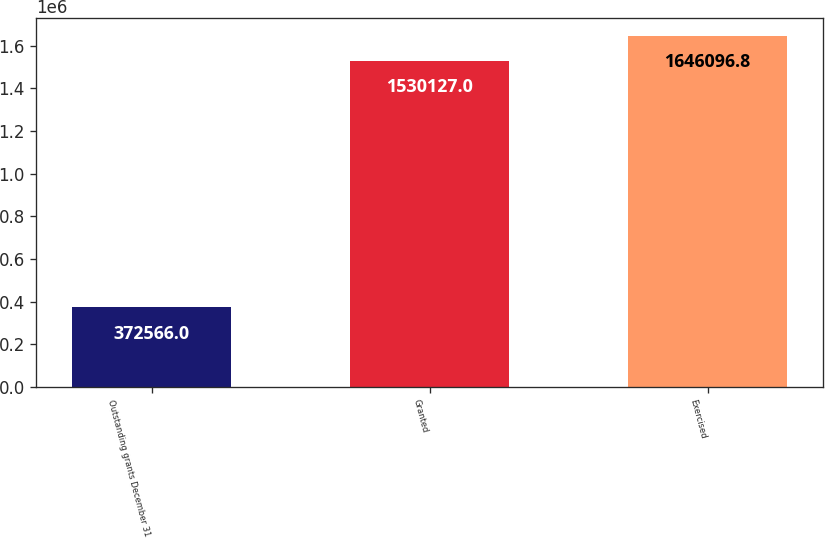Convert chart to OTSL. <chart><loc_0><loc_0><loc_500><loc_500><bar_chart><fcel>Outstanding grants December 31<fcel>Granted<fcel>Exercised<nl><fcel>372566<fcel>1.53013e+06<fcel>1.6461e+06<nl></chart> 